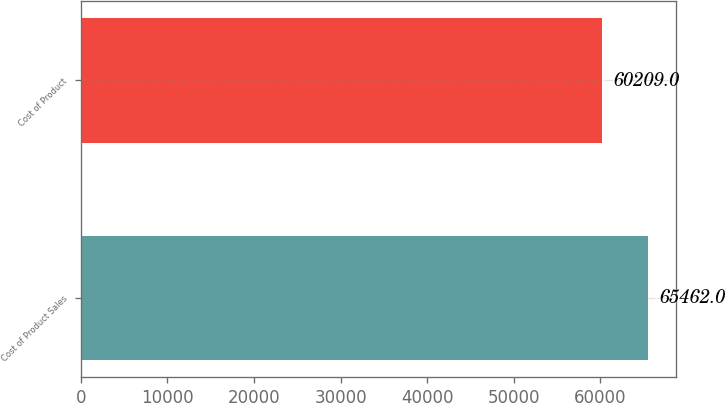Convert chart. <chart><loc_0><loc_0><loc_500><loc_500><bar_chart><fcel>Cost of Product Sales<fcel>Cost of Product<nl><fcel>65462<fcel>60209<nl></chart> 